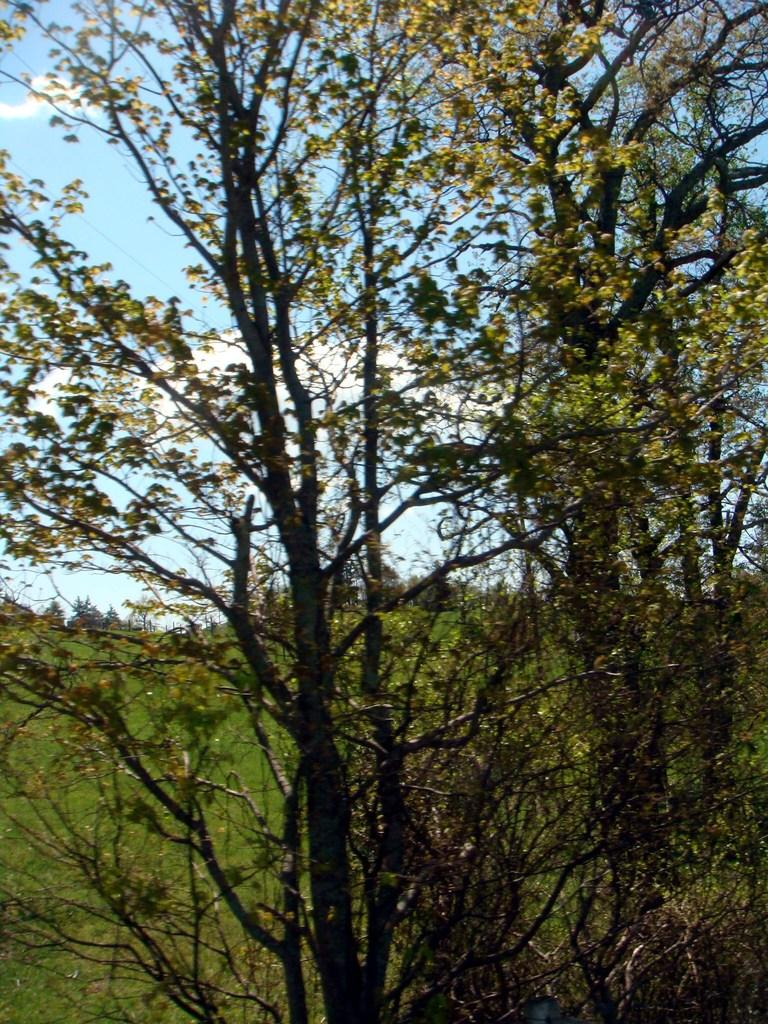What is located in the middle of the image? There are trees in the middle of the image. What can be seen in the background of the image? The sky is visible in the background of the image. How many pizzas are hanging from the trees in the image? There are no pizzas present in the image; it features trees and a sky background. 